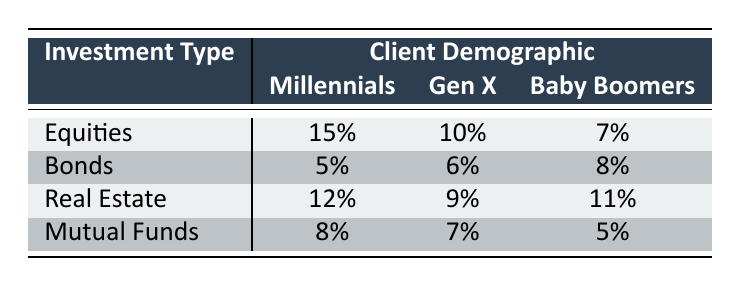What is the portfolio performance for Millennials in Equities? The table indicates that for the Investment Type "Equities," the Portfolio Performance for the demographic "Millennials" is 15.
Answer: 15 Which demographic has the highest Portfolio Performance in Bonds? In the Bonds category, the performance values are 5 for Millennials, 6 for Gen X, and 8 for Baby Boomers. The highest value is 8, which corresponds to Baby Boomers.
Answer: Baby Boomers What is the average Portfolio Performance across all Investment Types for Gen X? To find the average for Gen X, I sum the values: (10 from Equities + 6 from Bonds + 9 from Real Estate + 7 from Mutual Funds) = 32. There are 4 data points, so the average is 32 / 4 = 8.
Answer: 8 Is the Portfolio Performance in Real Estate better for Millennials than for Gen X? The performance for Millennials in Real Estate is 12, while for Gen X it is 9. Since 12 is greater than 9, the statement is true.
Answer: Yes What is the difference in Portfolio Performance between Baby Boomers in Equities and in Mutual Funds? The performance for Baby Boomers in Equities is 7 and in Mutual Funds is 5. The difference is 7 - 5 = 2.
Answer: 2 Which Investment Type overall has the lowest Portfolio Performance? By examining the lowest values for each Investment Type: Equities (7), Bonds (5), Real Estate (9), and Mutual Funds (5), the lowest are for Bonds and Mutual Funds, both with 5.
Answer: Bonds and Mutual Funds Is it true that Millennials perform better in Real Estate compared to Bonds? The performance for Millennials in Real Estate is 12 and in Bonds is 5. 12 is greater than 5, thus this statement is true.
Answer: Yes What is the total Portfolio Performance for all investment types of Baby Boomers? For Baby Boomers, the performance values are: 7 (Equities) + 8 (Bonds) + 11 (Real Estate) + 5 (Mutual Funds) = 31, so the total is 31.
Answer: 31 Which demographic has the lowest Portfolio Performance in Equities? The lowest performance in Equities is 7 for Baby Boomers compared to 15 for Millennials and 10 for Gen X.
Answer: Baby Boomers 